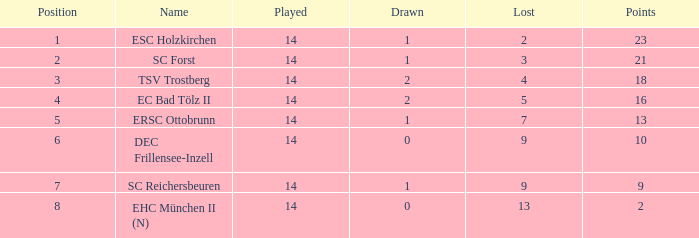What is the highest point with a drawn less than 2, a name as esc holzkirchen, and played less than 14? None. 